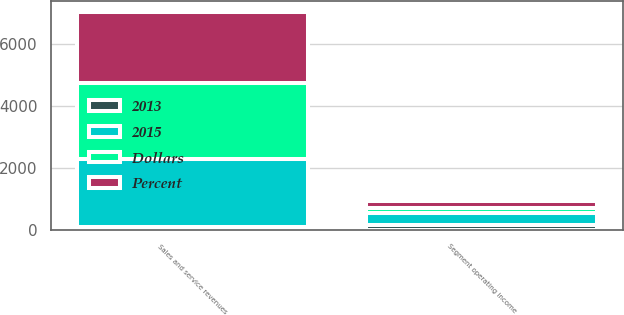Convert chart to OTSL. <chart><loc_0><loc_0><loc_500><loc_500><stacked_bar_chart><ecel><fcel>Sales and service revenues<fcel>Segment operating income<nl><fcel>2015<fcel>2188<fcel>379<nl><fcel>Percent<fcel>2286<fcel>229<nl><fcel>Dollars<fcel>2441<fcel>165<nl><fcel>2013<fcel>98<fcel>150<nl></chart> 